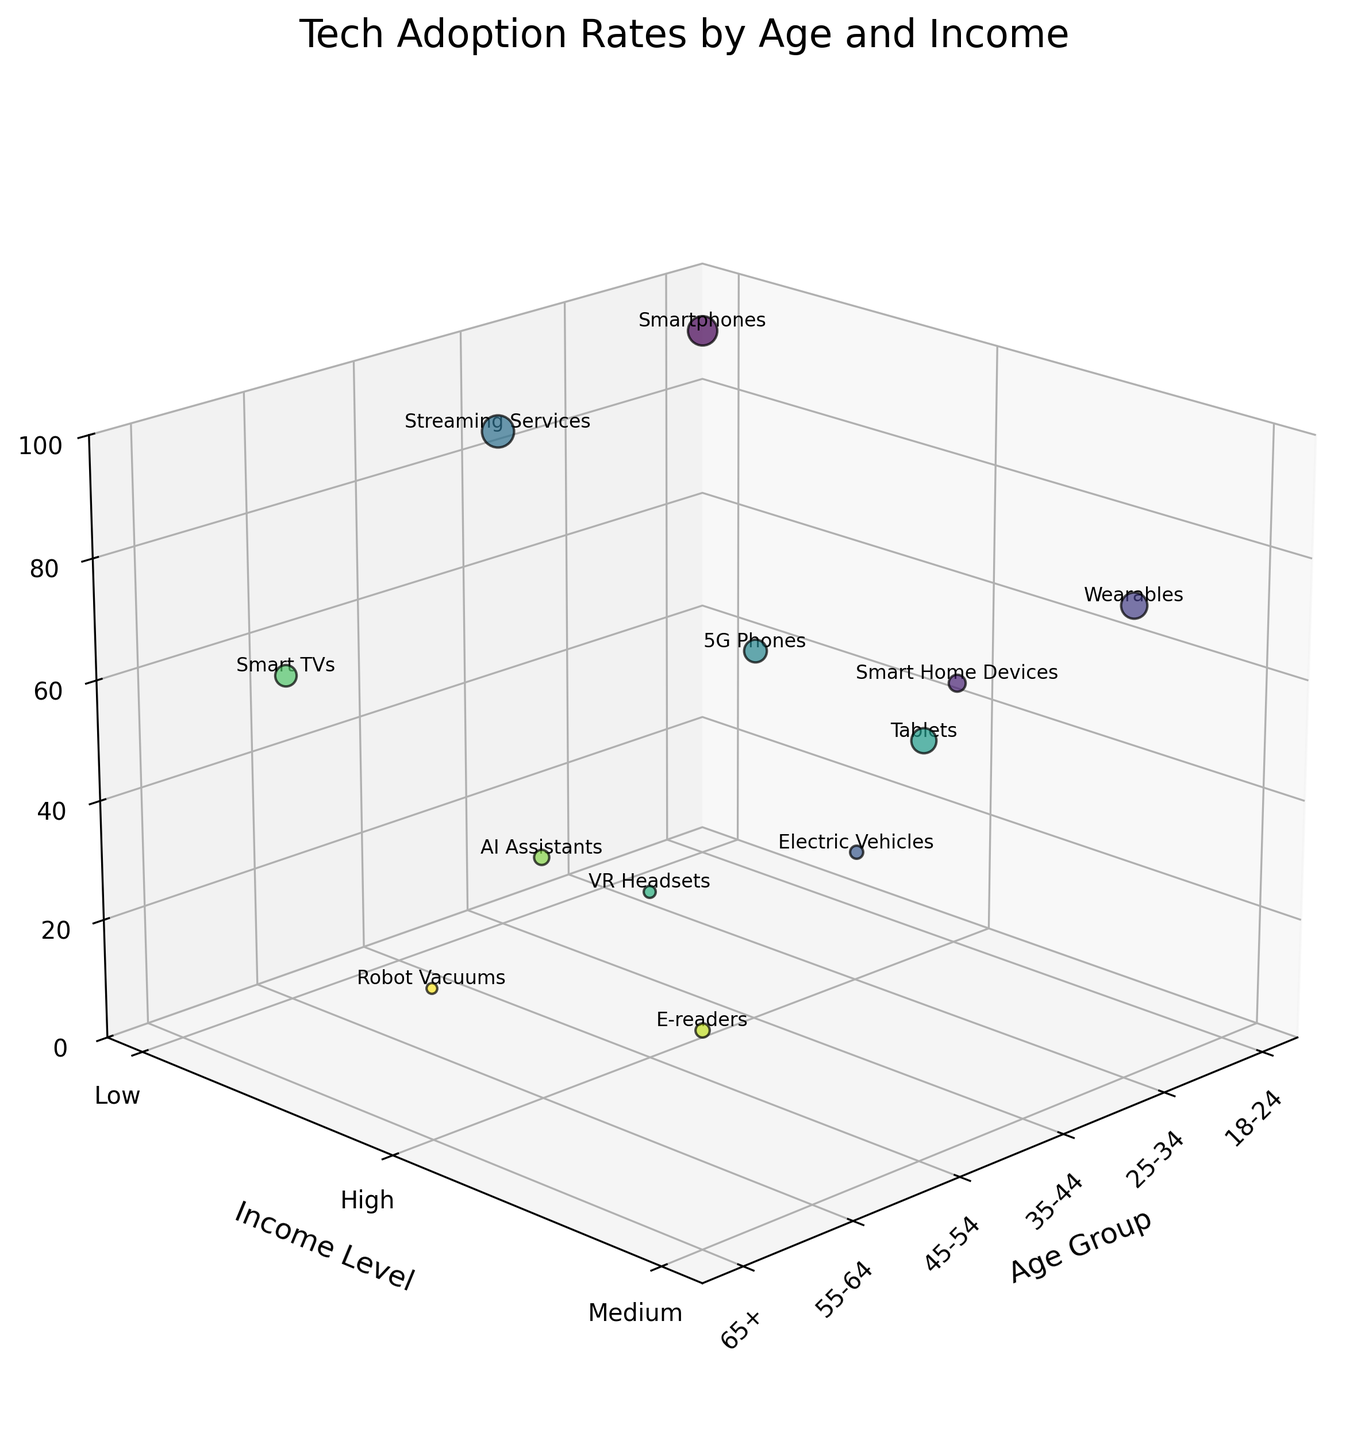What's the title of the figure? The title of the figure is typically shown at the top in larger font compared to other texts on the plot. In this figure, it is displayed as 'Tech Adoption Rates by Age and Income'.
Answer: Tech Adoption Rates by Age and Income How many age groups are represented in the plot? The number of age groups can be determined by counting the labels along the x-axis. There are six unique age groups labeled: '18-24', '25-34', '35-44', '45-54', '55-64', and '65+'.
Answer: Six Which technology has the highest adoption rate among high-income 25-34 age group? Locate the '25-34' age group on the x-axis and the high-income level on the y-axis, then check the z-axis for the highest point within that category. The technology labeled there is 'Electric Vehicles'.
Answer: Electric Vehicles What is the average adoption rate for technologies among the low-income groups? Identify the adoption rates for all bubbles within the 'Low' income level, which are labeled '18-24 Smartphones: 92', '35-44 Streaming Services: 85', and '55-64 Smart TVs: 55'. Add these values (92 + 85 + 55 = 232) and divide by the number of data points (3).
Answer: 77.33 Which age group has the smallest market size representation in the plot? The size of the bubbles represents market size. Identify the smallest bubble, which corresponds to '65+ Robot Vacuums' with 2,000,000 in the market size data.
Answer: 65+ How does the adoption rate for Smart Home Devices in the high-income 18-24 age group compare to the VR Headsets in the high-income 45-54 age group? Locate the relevant bubbles for both high-income 18-24 and high-income 45-54 groups. The adoption rate for Smart Home Devices is 45% and for VR Headsets is 28%. Therefore, Smart Home Devices have a higher adoption rate.
Answer: Higher What is the median adoption rate for all technologies across different age groups and income levels? List the adoption rates: 92, 45, 78, 22, 85, 62, 68, 28, 55, 40, 35, 25. Arrange them in ascending order: 22, 25, 28, 35, 40, 45, 55, 62, 68, 78, 85, 92. With an even number of entries, the median is the average of the 6th and 7th values: (45 + 55)/2 = 50.
Answer: 50 For the high-income group, which technology has the largest market size? In the plot, compare the sizes of the bubbles within the high-income level on the y-axis. The largest bubble within this group corresponds to '5G Phones' with a market size of 9,000,000.
Answer: 5G Phones Between Medium income groups of '25-34' and '45-54' age, which technology has the higher adoption rate? Compare 'Wearables' for '25-34' (78%) with 'Tablets' for '45-54' (68%). The adoption rate of 'Wearables' is higher than 'Tablets'.
Answer: Wearables 